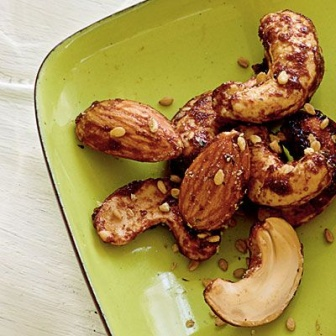Describe a realistic scenario where someone might encounter this dish. Someone might encounter this dish at a cozy, farmhouse kitchen gathering. With a group of friends enjoying an evening together, the host serves these freshly roasted nuts as a perfect snack alongside a selection of homemade drinks. The rustic setting, with its wooden table and vintage dinnerware, creates a heartwarming atmosphere where everyone feels at home. The nuts are a highlight due to their warm, seasoned flavor and the care taken in their presentation, making them an instant hit among the guests.  Describe another realistic scenario briefly. This dish could also be found at a contemporary café, served as a complimentary snack alongside a side of herbal tea, inviting customers to relax and enjoy a moment of calm amidst their busy day. 